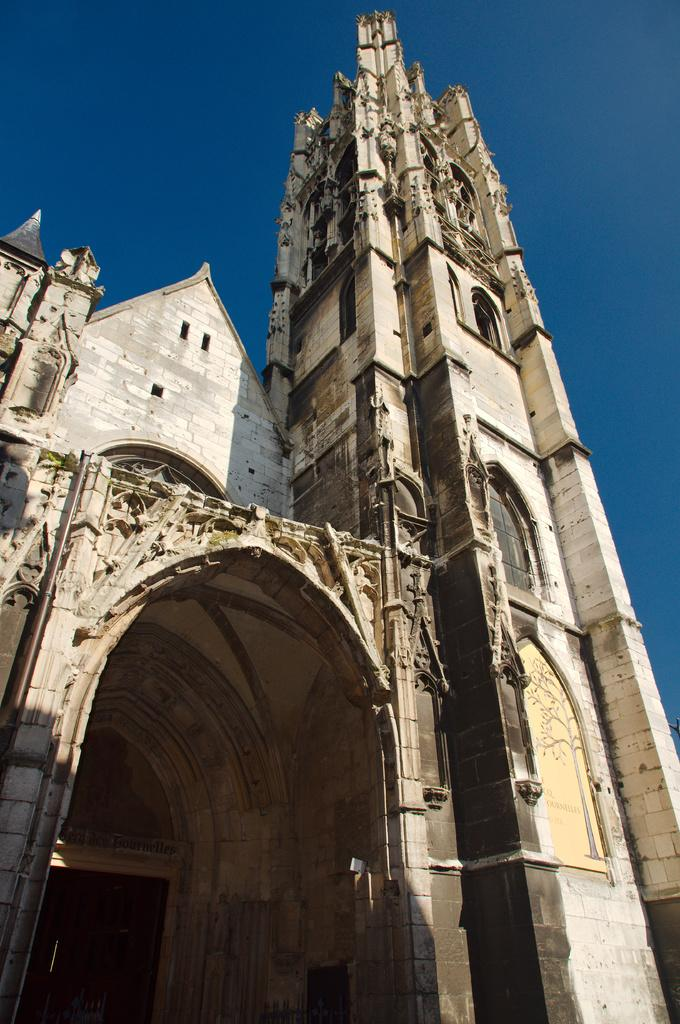What type of structure is present in the image? There is a building in the image. What can be seen in the background of the image? The sky is visible in the background of the image. What type of cracker is being eaten in the alley next to the building in the image? There is no cracker or alley present in the image; it only features a building and the sky in the background. 